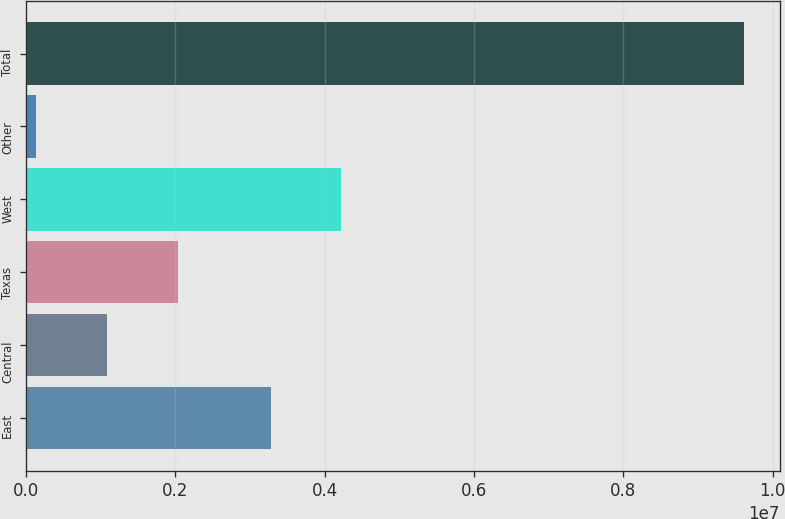Convert chart to OTSL. <chart><loc_0><loc_0><loc_500><loc_500><bar_chart><fcel>East<fcel>Central<fcel>Texas<fcel>West<fcel>Other<fcel>Total<nl><fcel>3.27607e+06<fcel>1.08786e+06<fcel>2.03523e+06<fcel>4.22344e+06<fcel>140497<fcel>9.61415e+06<nl></chart> 